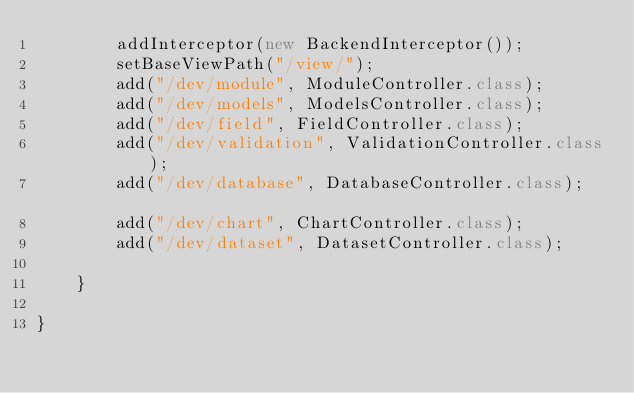<code> <loc_0><loc_0><loc_500><loc_500><_Java_>	    addInterceptor(new BackendInterceptor());
	    setBaseViewPath("/view/");
		add("/dev/module", ModuleController.class);
		add("/dev/models", ModelsController.class);
		add("/dev/field", FieldController.class);	
		add("/dev/validation", ValidationController.class);	
		add("/dev/database", DatabaseController.class);		
		add("/dev/chart", ChartController.class);
		add("/dev/dataset", DatasetController.class);
		
	}

}
</code> 